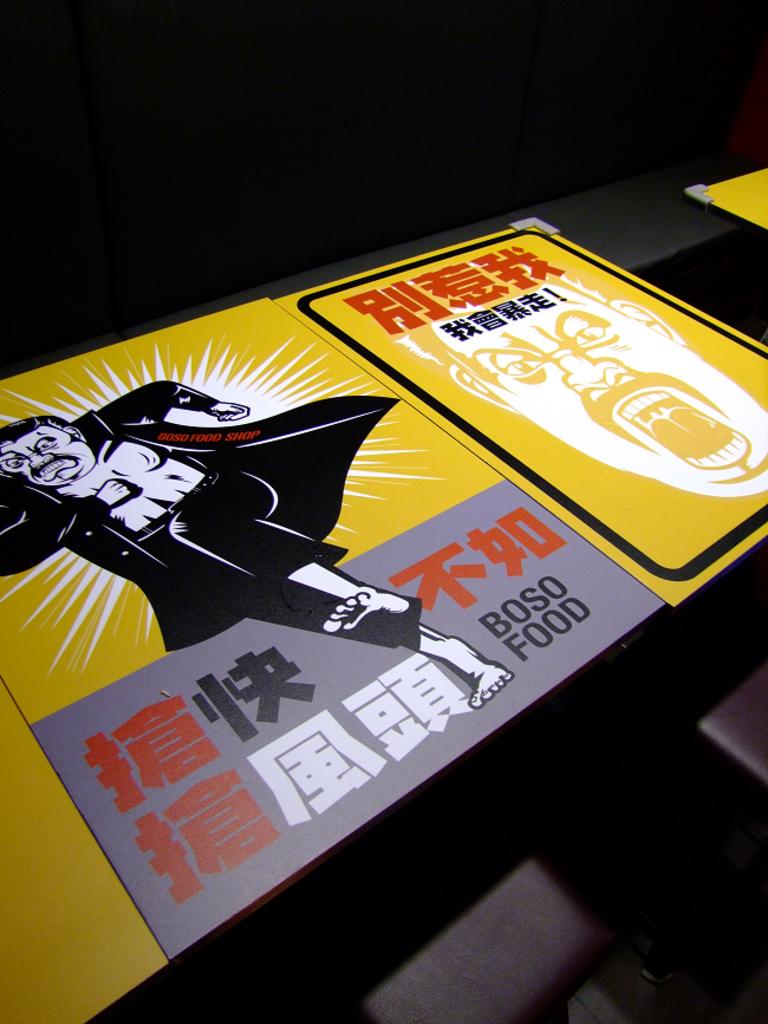Is this a food magazine?
Your response must be concise. Unanswerable. 